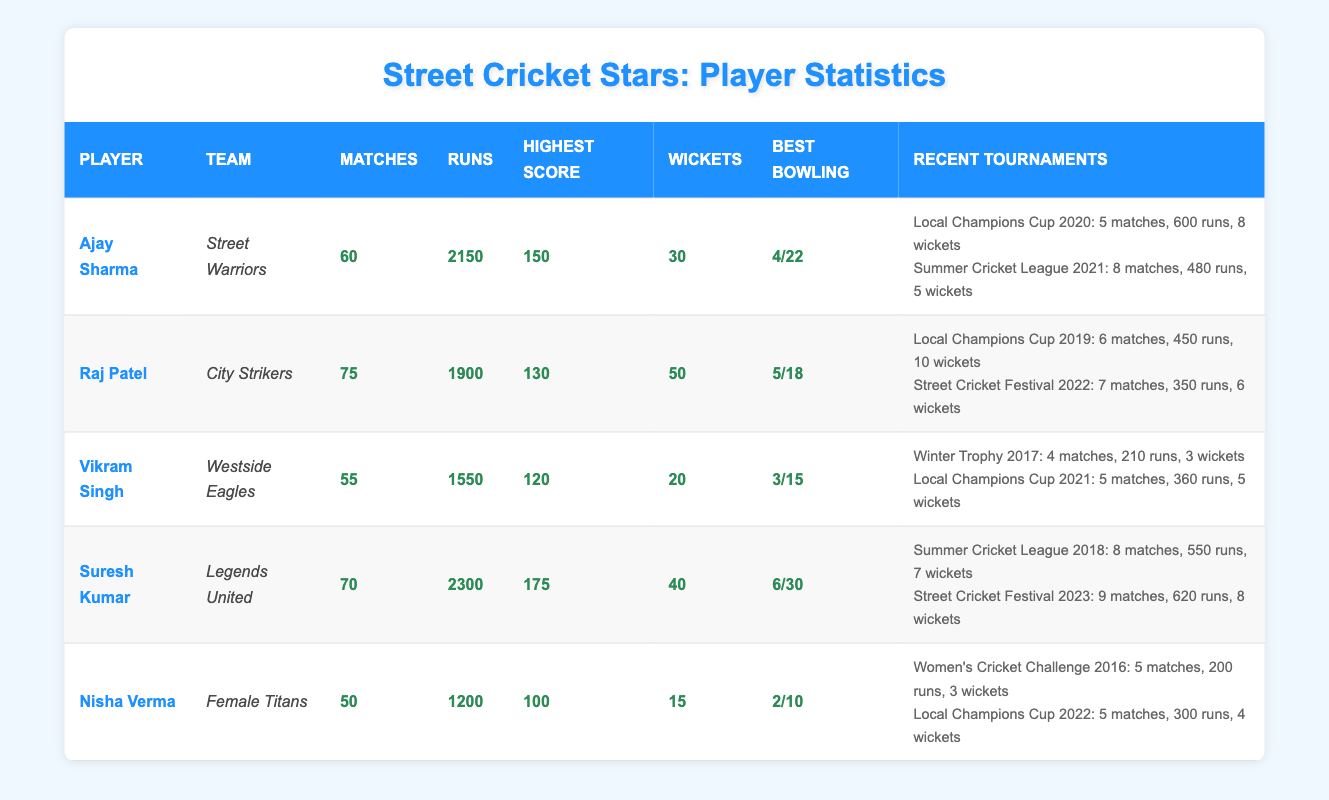What is the highest score achieved by Suresh Kumar? Suresh Kumar's highest score, as mentioned in the table, is 175.
Answer: 175 How many matches has Raj Patel played in total? The total matches played by Raj Patel is 75, as stated in the table.
Answer: 75 Which player has taken the most wickets? Raj Patel has taken the most wickets with a total of 50 wickets according to the table.
Answer: Raj Patel What is the combined total of runs scored by Ajay Sharma and Nisha Verma? Ajay Sharma scored 2150 runs and Nisha Verma scored 1200 runs; summing them gives 2150 + 1200 = 3350 runs.
Answer: 3350 Did Vikram Singh participate in tournaments in 2021? Yes, Vikram Singh participated in the Local Champions Cup in 2021.
Answer: Yes Who has the best bowling figure among the players? Suresh Kumar has the best bowling figure of 6/30, which is the lowest runs conceded with the highest wickets taken among the players.
Answer: Suresh Kumar What is the average number of wickets taken by players in the table? The total wickets taken by all players is 30 + 50 + 20 + 40 + 15 = 155. Dividing by 5 players gives an average of 155 / 5 = 31.
Answer: 31 In which tournament did Nisha Verma score the highest runs? Nisha Verma scored 300 runs in the Local Champions Cup in 2022, which is higher than her other tournament run total.
Answer: Local Champions Cup 2022 Which player played the fewest matches? Vikram Singh played the fewest matches with a total of 55 matches played, as shown in the table.
Answer: Vikram Singh How many tournaments did Suresh Kumar play, and what was his total performance in those tournaments? Suresh Kumar participated in 2 tournaments. Total performance: 8 matches, 550 runs, 7 wickets in 2018 and 9 matches, 620 runs, 8 wickets in 2023.
Answer: 2 tournaments, 1170 runs, 15 wickets 